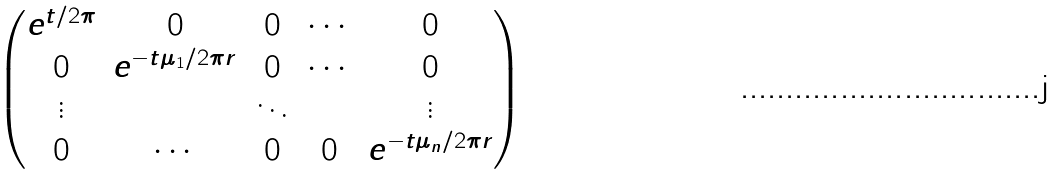Convert formula to latex. <formula><loc_0><loc_0><loc_500><loc_500>\begin{pmatrix} e ^ { t / 2 \pi } & 0 & 0 & \cdots & 0 \\ 0 & e ^ { - t \mu _ { 1 } / 2 \pi r } & 0 & \cdots & 0 \\ \vdots & & \ddots & & \vdots \\ 0 & \cdots & 0 & 0 & e ^ { - t \mu _ { n } / 2 \pi r } \\ \end{pmatrix}</formula> 